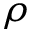<formula> <loc_0><loc_0><loc_500><loc_500>\rho</formula> 